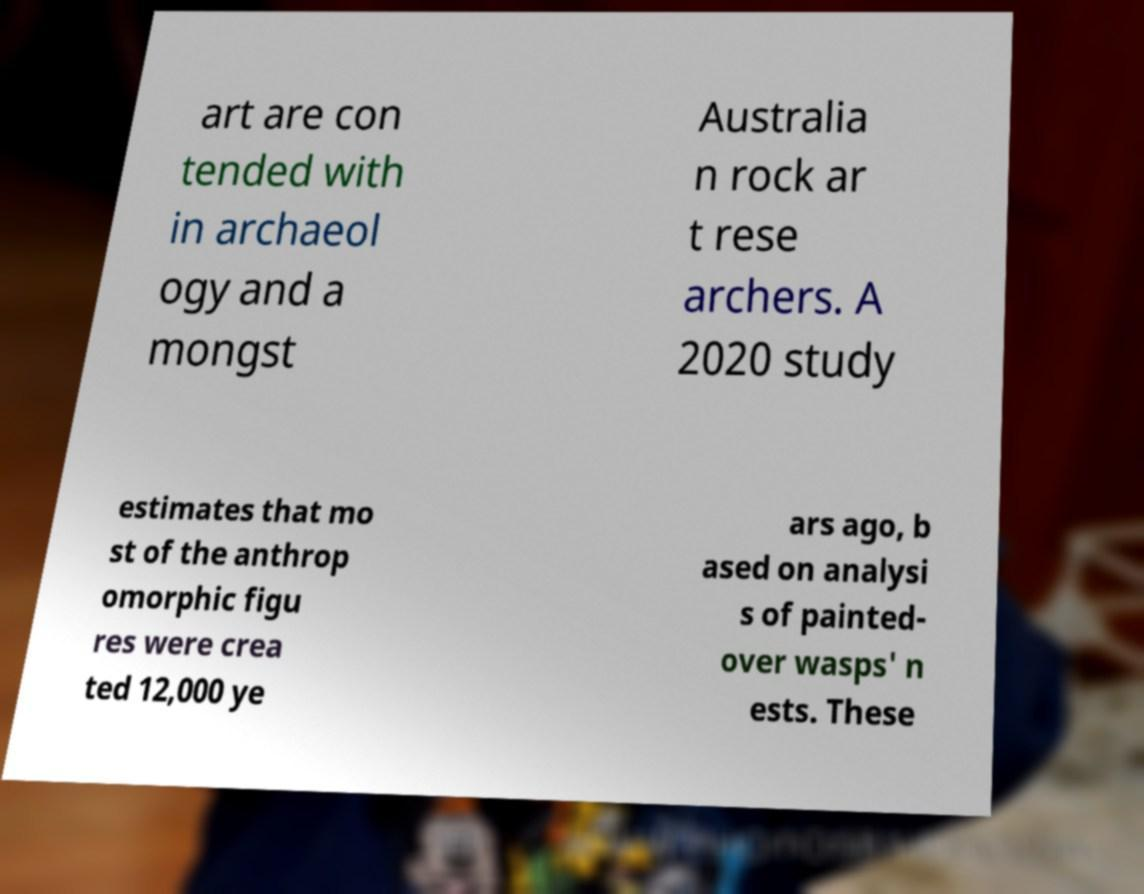Could you extract and type out the text from this image? art are con tended with in archaeol ogy and a mongst Australia n rock ar t rese archers. A 2020 study estimates that mo st of the anthrop omorphic figu res were crea ted 12,000 ye ars ago, b ased on analysi s of painted- over wasps' n ests. These 